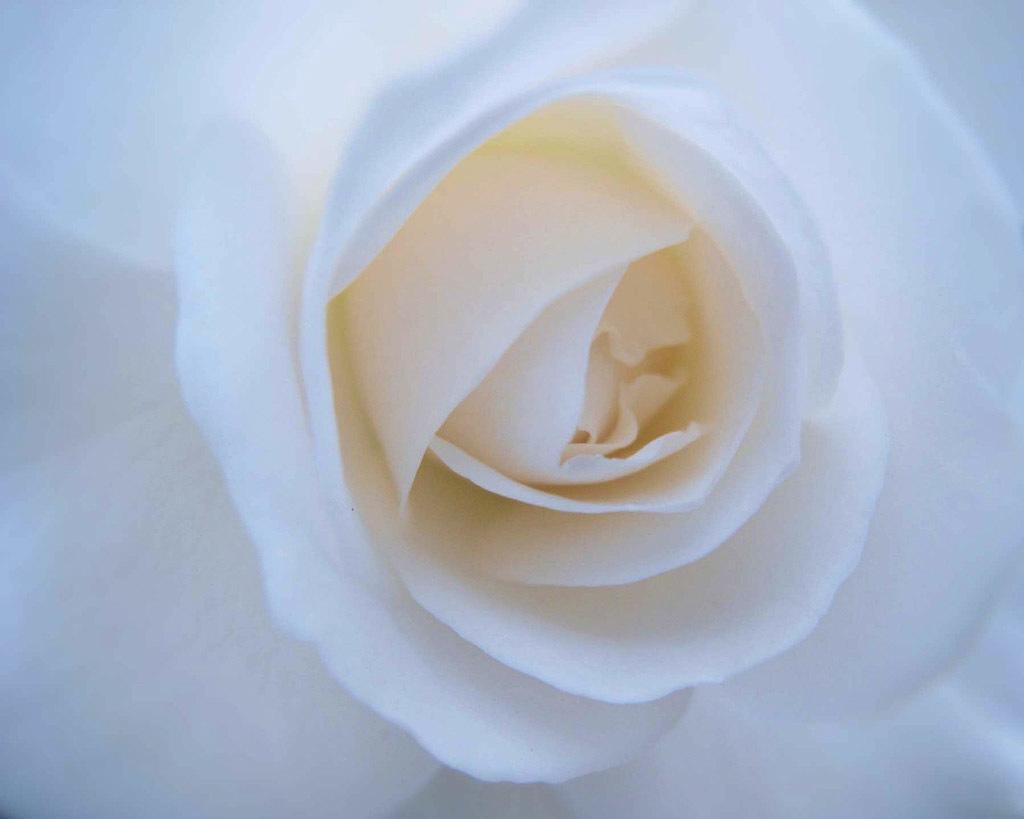In one or two sentences, can you explain what this image depicts? In this picture we can see a white flower. 